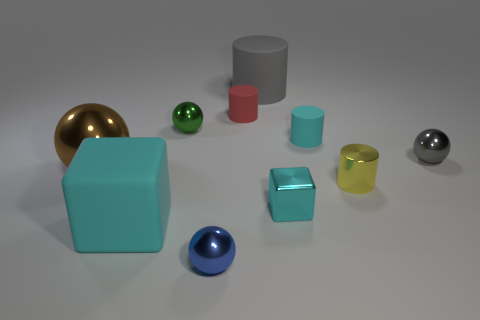Is there any indication of texture on any of the objects? Most objects appear smooth, but the green sphere and the yellow cylinder have a slight textural finish that gives them a more realistic appearance compared to the perfectly smooth objects. 